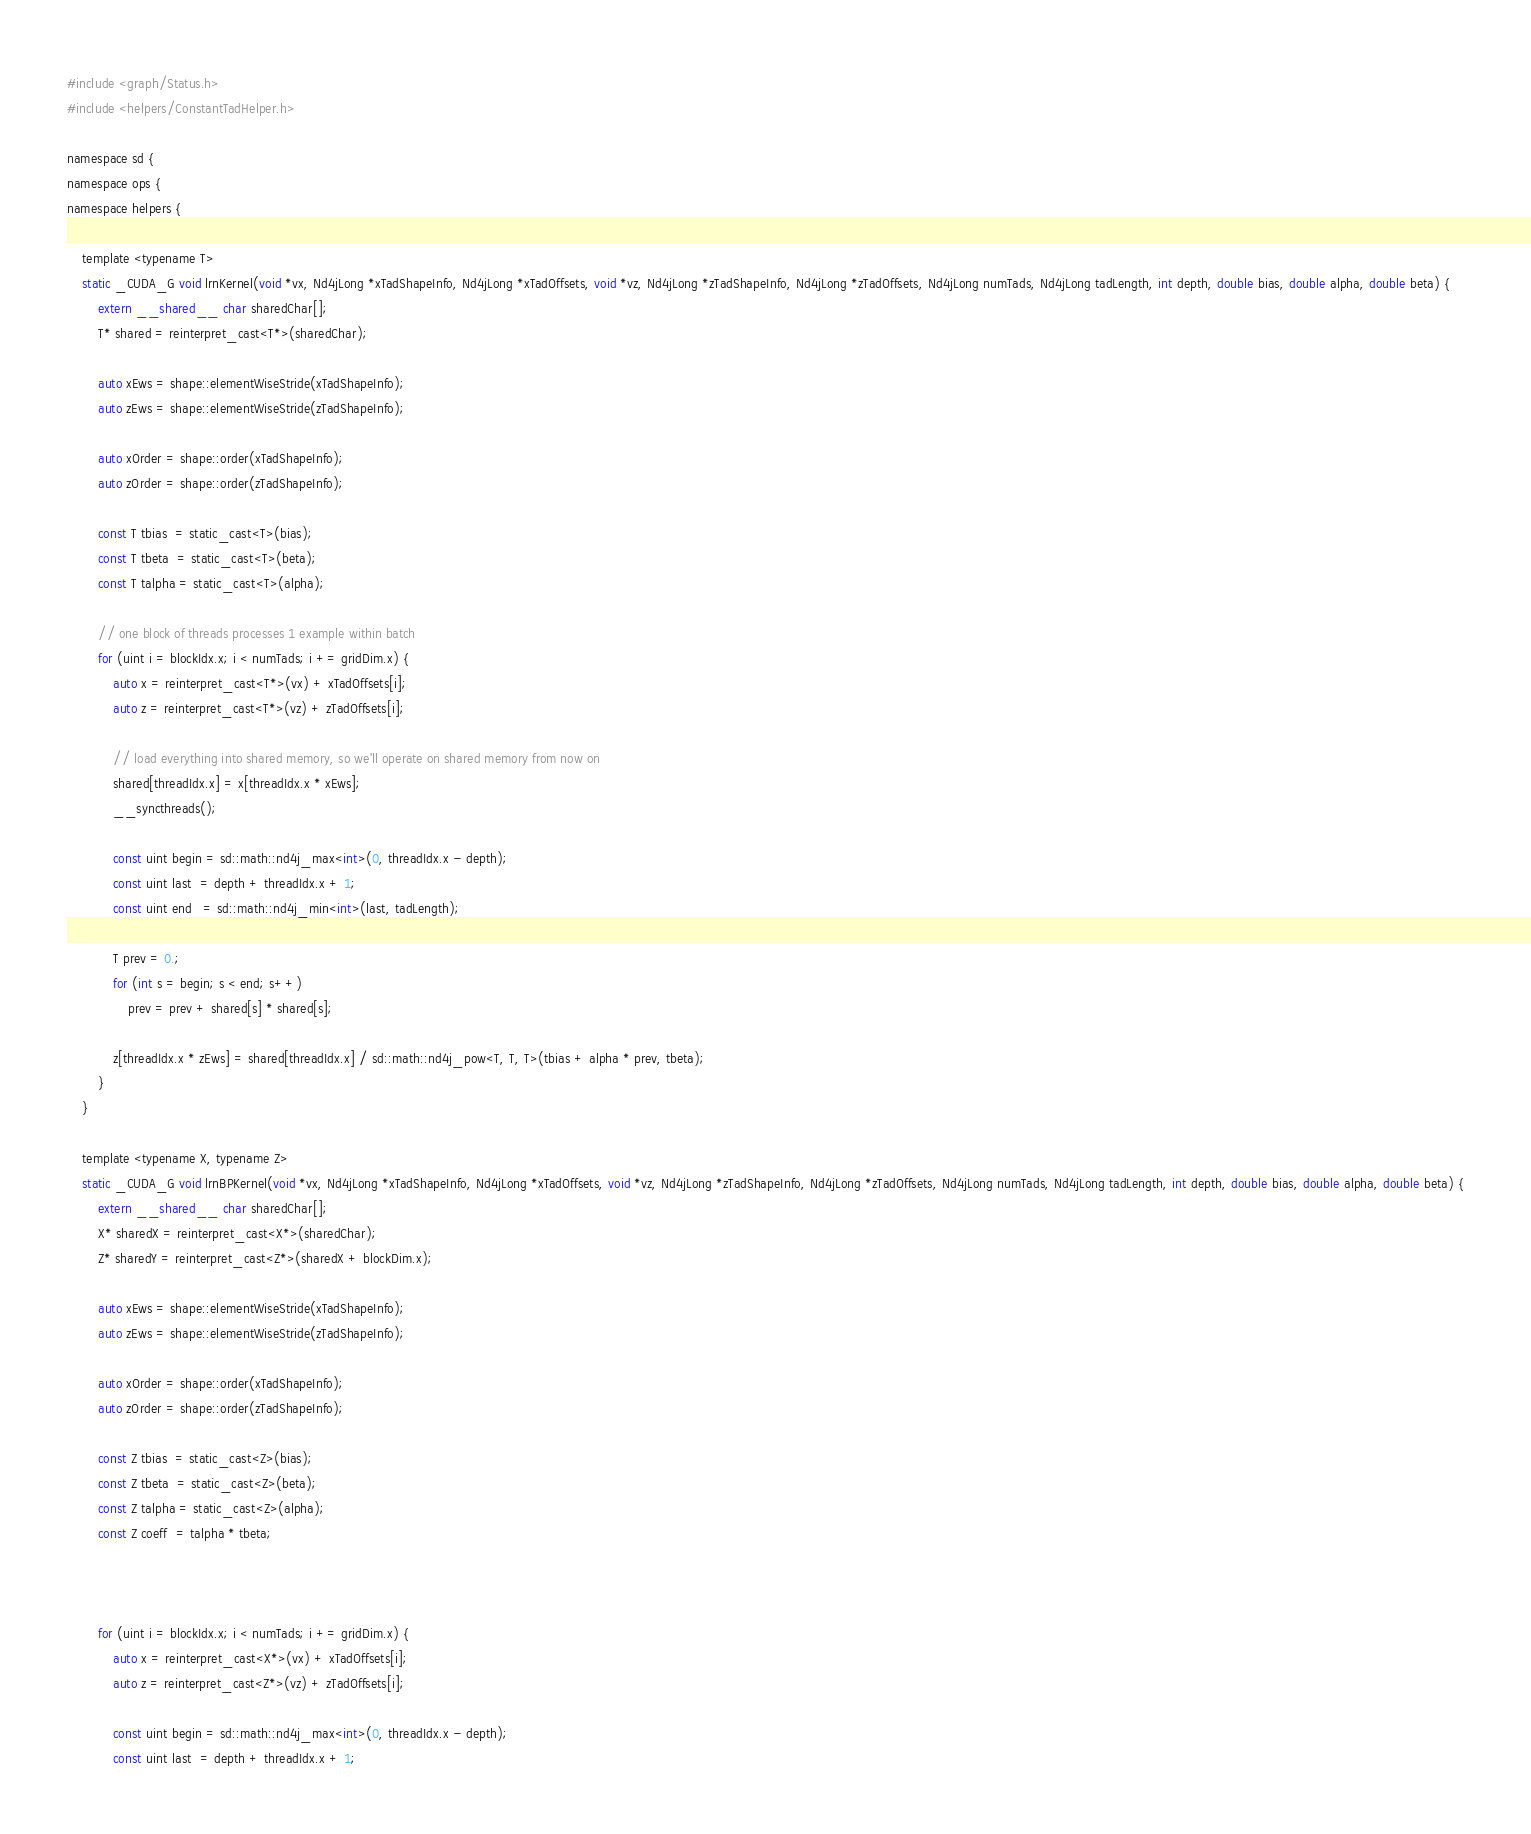<code> <loc_0><loc_0><loc_500><loc_500><_Cuda_>#include <graph/Status.h>
#include <helpers/ConstantTadHelper.h>

namespace sd {
namespace ops {
namespace helpers {

    template <typename T>
    static _CUDA_G void lrnKernel(void *vx, Nd4jLong *xTadShapeInfo, Nd4jLong *xTadOffsets, void *vz, Nd4jLong *zTadShapeInfo, Nd4jLong *zTadOffsets, Nd4jLong numTads, Nd4jLong tadLength, int depth, double bias, double alpha, double beta) {
        extern __shared__ char sharedChar[];
        T* shared = reinterpret_cast<T*>(sharedChar);

        auto xEws = shape::elementWiseStride(xTadShapeInfo);
        auto zEws = shape::elementWiseStride(zTadShapeInfo);

        auto xOrder = shape::order(xTadShapeInfo);
        auto zOrder = shape::order(zTadShapeInfo);

        const T tbias  = static_cast<T>(bias);
        const T tbeta  = static_cast<T>(beta);
        const T talpha = static_cast<T>(alpha);

        // one block of threads processes 1 example within batch
        for (uint i = blockIdx.x; i < numTads; i += gridDim.x) {
            auto x = reinterpret_cast<T*>(vx) + xTadOffsets[i];
            auto z = reinterpret_cast<T*>(vz) + zTadOffsets[i];

            // load everything into shared memory, so we'll operate on shared memory from now on
            shared[threadIdx.x] = x[threadIdx.x * xEws];
            __syncthreads();

            const uint begin = sd::math::nd4j_max<int>(0, threadIdx.x - depth);
            const uint last  = depth + threadIdx.x + 1;
            const uint end   = sd::math::nd4j_min<int>(last, tadLength);

            T prev = 0.;
            for (int s = begin; s < end; s++)
                prev = prev + shared[s] * shared[s];

            z[threadIdx.x * zEws] = shared[threadIdx.x] / sd::math::nd4j_pow<T, T, T>(tbias + alpha * prev, tbeta);
        }
    }

    template <typename X, typename Z>
    static _CUDA_G void lrnBPKernel(void *vx, Nd4jLong *xTadShapeInfo, Nd4jLong *xTadOffsets, void *vz, Nd4jLong *zTadShapeInfo, Nd4jLong *zTadOffsets, Nd4jLong numTads, Nd4jLong tadLength, int depth, double bias, double alpha, double beta) {
        extern __shared__ char sharedChar[];
        X* sharedX = reinterpret_cast<X*>(sharedChar);
        Z* sharedY = reinterpret_cast<Z*>(sharedX + blockDim.x);

        auto xEws = shape::elementWiseStride(xTadShapeInfo);
        auto zEws = shape::elementWiseStride(zTadShapeInfo);

        auto xOrder = shape::order(xTadShapeInfo);
        auto zOrder = shape::order(zTadShapeInfo);

        const Z tbias  = static_cast<Z>(bias);
        const Z tbeta  = static_cast<Z>(beta);
        const Z talpha = static_cast<Z>(alpha);
        const Z coeff  = talpha * tbeta;



        for (uint i = blockIdx.x; i < numTads; i += gridDim.x) {
            auto x = reinterpret_cast<X*>(vx) + xTadOffsets[i];
            auto z = reinterpret_cast<Z*>(vz) + zTadOffsets[i];

            const uint begin = sd::math::nd4j_max<int>(0, threadIdx.x - depth);
            const uint last  = depth + threadIdx.x + 1;</code> 